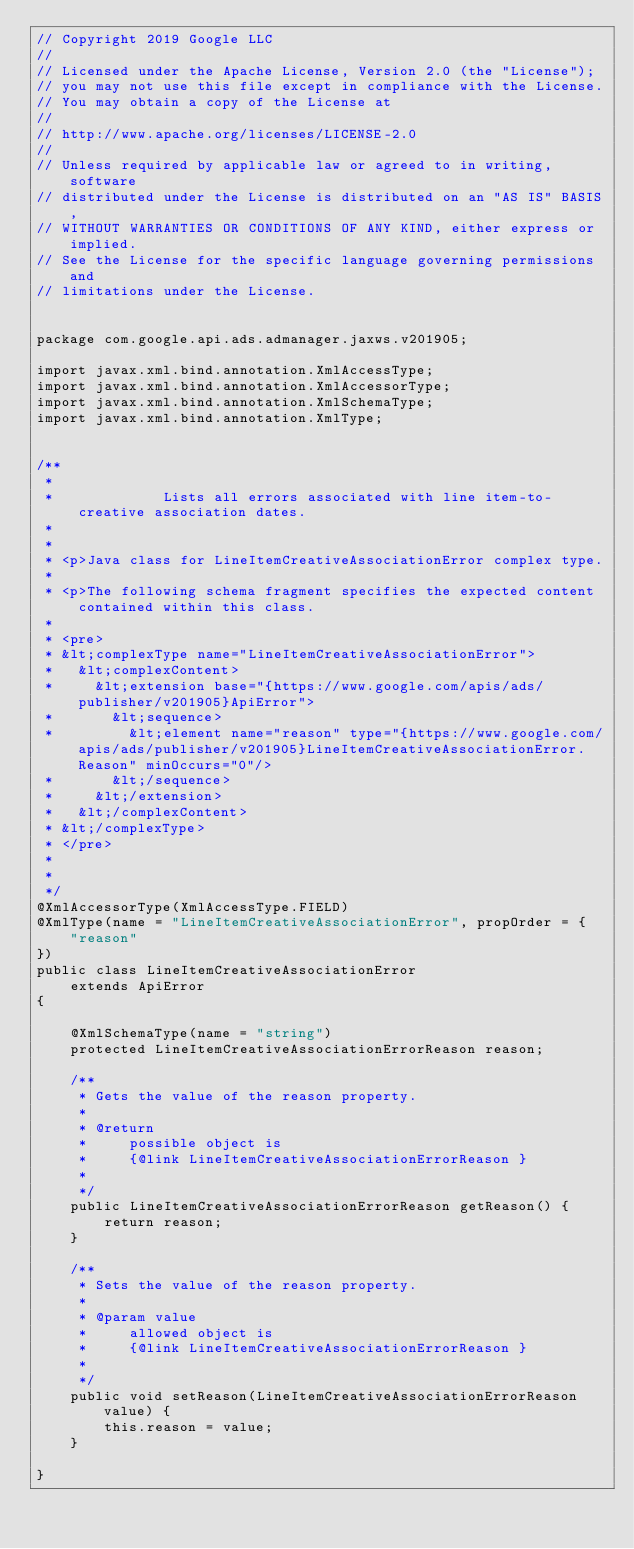Convert code to text. <code><loc_0><loc_0><loc_500><loc_500><_Java_>// Copyright 2019 Google LLC
//
// Licensed under the Apache License, Version 2.0 (the "License");
// you may not use this file except in compliance with the License.
// You may obtain a copy of the License at
//
// http://www.apache.org/licenses/LICENSE-2.0
//
// Unless required by applicable law or agreed to in writing, software
// distributed under the License is distributed on an "AS IS" BASIS,
// WITHOUT WARRANTIES OR CONDITIONS OF ANY KIND, either express or implied.
// See the License for the specific language governing permissions and
// limitations under the License.


package com.google.api.ads.admanager.jaxws.v201905;

import javax.xml.bind.annotation.XmlAccessType;
import javax.xml.bind.annotation.XmlAccessorType;
import javax.xml.bind.annotation.XmlSchemaType;
import javax.xml.bind.annotation.XmlType;


/**
 * 
 *             Lists all errors associated with line item-to-creative association dates.
 *           
 * 
 * <p>Java class for LineItemCreativeAssociationError complex type.
 * 
 * <p>The following schema fragment specifies the expected content contained within this class.
 * 
 * <pre>
 * &lt;complexType name="LineItemCreativeAssociationError">
 *   &lt;complexContent>
 *     &lt;extension base="{https://www.google.com/apis/ads/publisher/v201905}ApiError">
 *       &lt;sequence>
 *         &lt;element name="reason" type="{https://www.google.com/apis/ads/publisher/v201905}LineItemCreativeAssociationError.Reason" minOccurs="0"/>
 *       &lt;/sequence>
 *     &lt;/extension>
 *   &lt;/complexContent>
 * &lt;/complexType>
 * </pre>
 * 
 * 
 */
@XmlAccessorType(XmlAccessType.FIELD)
@XmlType(name = "LineItemCreativeAssociationError", propOrder = {
    "reason"
})
public class LineItemCreativeAssociationError
    extends ApiError
{

    @XmlSchemaType(name = "string")
    protected LineItemCreativeAssociationErrorReason reason;

    /**
     * Gets the value of the reason property.
     * 
     * @return
     *     possible object is
     *     {@link LineItemCreativeAssociationErrorReason }
     *     
     */
    public LineItemCreativeAssociationErrorReason getReason() {
        return reason;
    }

    /**
     * Sets the value of the reason property.
     * 
     * @param value
     *     allowed object is
     *     {@link LineItemCreativeAssociationErrorReason }
     *     
     */
    public void setReason(LineItemCreativeAssociationErrorReason value) {
        this.reason = value;
    }

}
</code> 